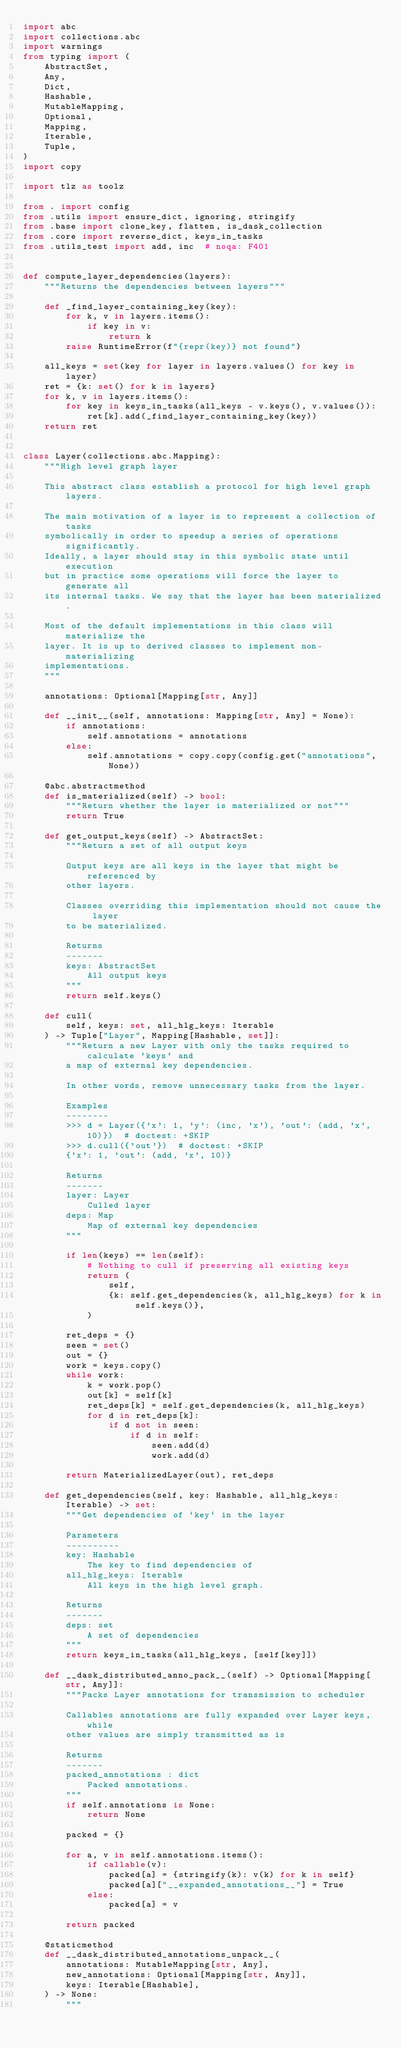<code> <loc_0><loc_0><loc_500><loc_500><_Python_>import abc
import collections.abc
import warnings
from typing import (
    AbstractSet,
    Any,
    Dict,
    Hashable,
    MutableMapping,
    Optional,
    Mapping,
    Iterable,
    Tuple,
)
import copy

import tlz as toolz

from . import config
from .utils import ensure_dict, ignoring, stringify
from .base import clone_key, flatten, is_dask_collection
from .core import reverse_dict, keys_in_tasks
from .utils_test import add, inc  # noqa: F401


def compute_layer_dependencies(layers):
    """Returns the dependencies between layers"""

    def _find_layer_containing_key(key):
        for k, v in layers.items():
            if key in v:
                return k
        raise RuntimeError(f"{repr(key)} not found")

    all_keys = set(key for layer in layers.values() for key in layer)
    ret = {k: set() for k in layers}
    for k, v in layers.items():
        for key in keys_in_tasks(all_keys - v.keys(), v.values()):
            ret[k].add(_find_layer_containing_key(key))
    return ret


class Layer(collections.abc.Mapping):
    """High level graph layer

    This abstract class establish a protocol for high level graph layers.

    The main motivation of a layer is to represent a collection of tasks
    symbolically in order to speedup a series of operations significantly.
    Ideally, a layer should stay in this symbolic state until execution
    but in practice some operations will force the layer to generate all
    its internal tasks. We say that the layer has been materialized.

    Most of the default implementations in this class will materialize the
    layer. It is up to derived classes to implement non-materializing
    implementations.
    """

    annotations: Optional[Mapping[str, Any]]

    def __init__(self, annotations: Mapping[str, Any] = None):
        if annotations:
            self.annotations = annotations
        else:
            self.annotations = copy.copy(config.get("annotations", None))

    @abc.abstractmethod
    def is_materialized(self) -> bool:
        """Return whether the layer is materialized or not"""
        return True

    def get_output_keys(self) -> AbstractSet:
        """Return a set of all output keys

        Output keys are all keys in the layer that might be referenced by
        other layers.

        Classes overriding this implementation should not cause the layer
        to be materialized.

        Returns
        -------
        keys: AbstractSet
            All output keys
        """
        return self.keys()

    def cull(
        self, keys: set, all_hlg_keys: Iterable
    ) -> Tuple["Layer", Mapping[Hashable, set]]:
        """Return a new Layer with only the tasks required to calculate `keys` and
        a map of external key dependencies.

        In other words, remove unnecessary tasks from the layer.

        Examples
        --------
        >>> d = Layer({'x': 1, 'y': (inc, 'x'), 'out': (add, 'x', 10)})  # doctest: +SKIP
        >>> d.cull({'out'})  # doctest: +SKIP
        {'x': 1, 'out': (add, 'x', 10)}

        Returns
        -------
        layer: Layer
            Culled layer
        deps: Map
            Map of external key dependencies
        """

        if len(keys) == len(self):
            # Nothing to cull if preserving all existing keys
            return (
                self,
                {k: self.get_dependencies(k, all_hlg_keys) for k in self.keys()},
            )

        ret_deps = {}
        seen = set()
        out = {}
        work = keys.copy()
        while work:
            k = work.pop()
            out[k] = self[k]
            ret_deps[k] = self.get_dependencies(k, all_hlg_keys)
            for d in ret_deps[k]:
                if d not in seen:
                    if d in self:
                        seen.add(d)
                        work.add(d)

        return MaterializedLayer(out), ret_deps

    def get_dependencies(self, key: Hashable, all_hlg_keys: Iterable) -> set:
        """Get dependencies of `key` in the layer

        Parameters
        ----------
        key: Hashable
            The key to find dependencies of
        all_hlg_keys: Iterable
            All keys in the high level graph.

        Returns
        -------
        deps: set
            A set of dependencies
        """
        return keys_in_tasks(all_hlg_keys, [self[key]])

    def __dask_distributed_anno_pack__(self) -> Optional[Mapping[str, Any]]:
        """Packs Layer annotations for transmission to scheduler

        Callables annotations are fully expanded over Layer keys, while
        other values are simply transmitted as is

        Returns
        -------
        packed_annotations : dict
            Packed annotations.
        """
        if self.annotations is None:
            return None

        packed = {}

        for a, v in self.annotations.items():
            if callable(v):
                packed[a] = {stringify(k): v(k) for k in self}
                packed[a]["__expanded_annotations__"] = True
            else:
                packed[a] = v

        return packed

    @staticmethod
    def __dask_distributed_annotations_unpack__(
        annotations: MutableMapping[str, Any],
        new_annotations: Optional[Mapping[str, Any]],
        keys: Iterable[Hashable],
    ) -> None:
        """</code> 